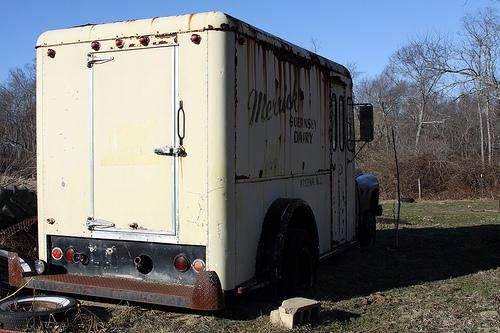Question: what kind of truck is it?
Choices:
A. Dairy truck.
B. Dump truck.
C. Garbage truck.
D. A mail truck.
Answer with the letter. Answer: A Question: where is the truck?
Choices:
A. In the garage.
B. In the driveway.
C. In a field.
D. In the park.
Answer with the letter. Answer: C Question: what has happened to the truck over time?
Choices:
A. Dirty.
B. Fell apart.
C. Paint came off.
D. Rusting.
Answer with the letter. Answer: D Question: what is the vehicle?
Choices:
A. Truck.
B. Car.
C. Motorcycle.
D. Tractor.
Answer with the letter. Answer: A 